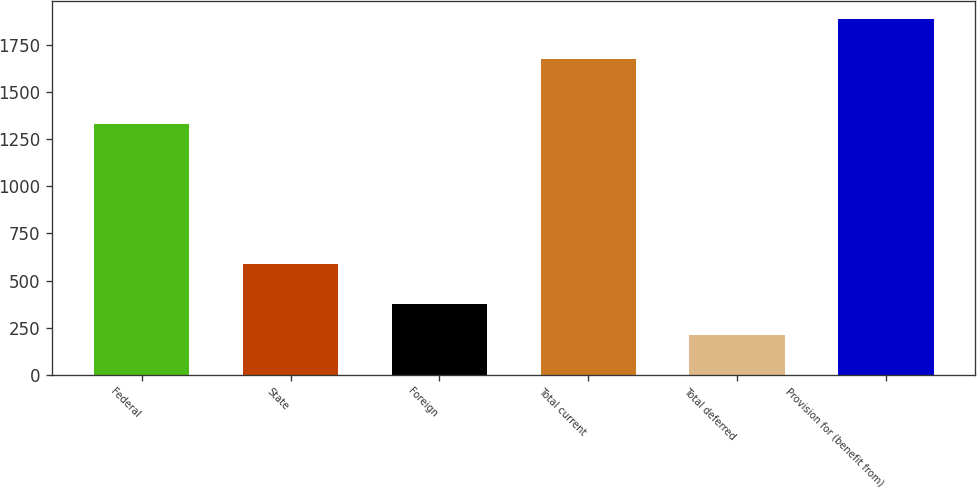Convert chart to OTSL. <chart><loc_0><loc_0><loc_500><loc_500><bar_chart><fcel>Federal<fcel>State<fcel>Foreign<fcel>Total current<fcel>Total deferred<fcel>Provision for (benefit from)<nl><fcel>1332<fcel>589<fcel>377.8<fcel>1678<fcel>210<fcel>1888<nl></chart> 